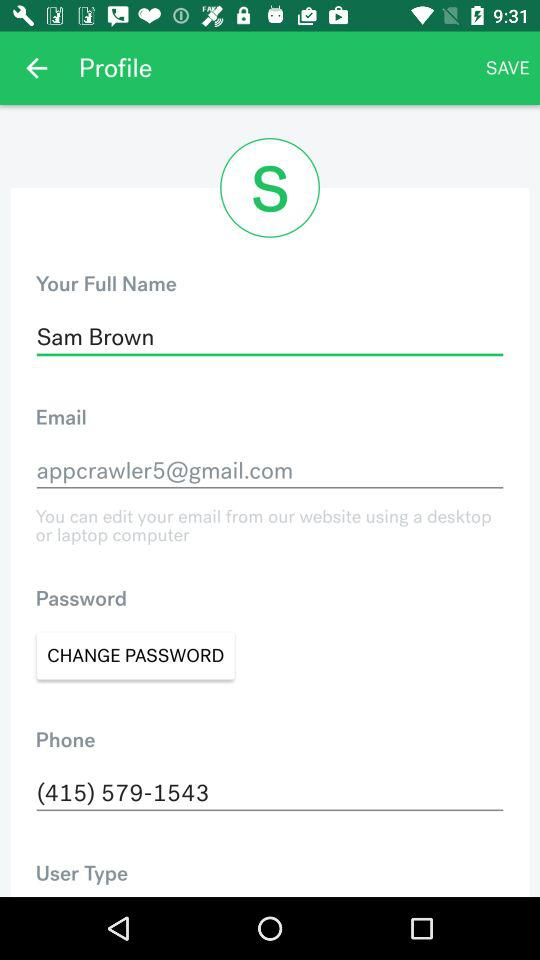What is the full name? The full name is Sam Brown. 